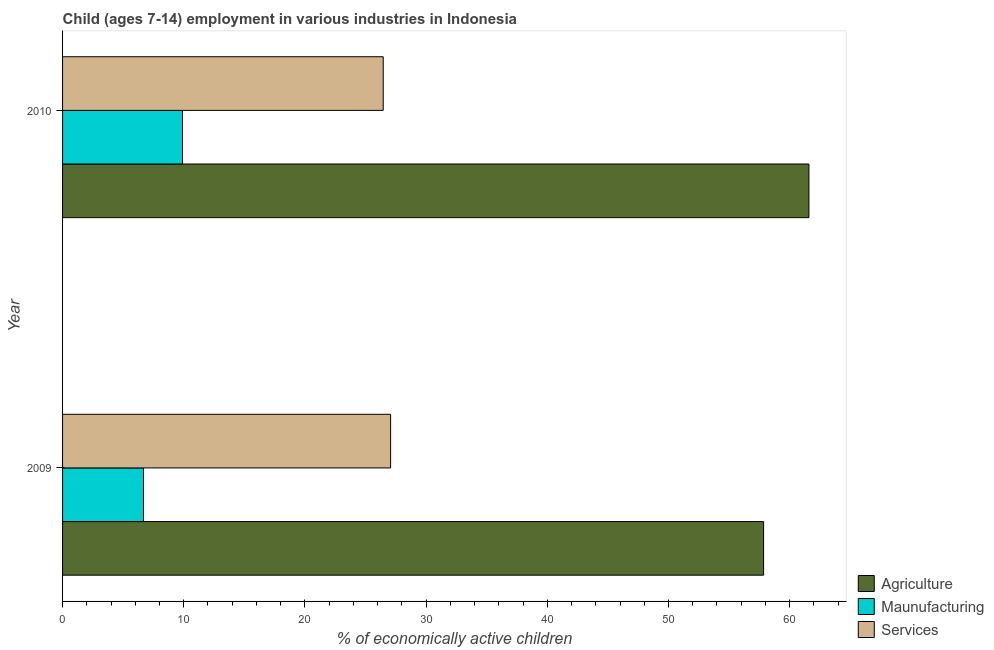How many groups of bars are there?
Make the answer very short. 2. Are the number of bars on each tick of the Y-axis equal?
Provide a short and direct response. Yes. What is the label of the 2nd group of bars from the top?
Ensure brevity in your answer.  2009. What is the percentage of economically active children in manufacturing in 2009?
Give a very brief answer. 6.68. Across all years, what is the maximum percentage of economically active children in agriculture?
Make the answer very short. 61.59. Across all years, what is the minimum percentage of economically active children in services?
Your answer should be compact. 26.46. In which year was the percentage of economically active children in services maximum?
Offer a terse response. 2009. In which year was the percentage of economically active children in services minimum?
Ensure brevity in your answer.  2010. What is the total percentage of economically active children in agriculture in the graph?
Keep it short and to the point. 119.44. What is the difference between the percentage of economically active children in services in 2009 and that in 2010?
Make the answer very short. 0.61. What is the difference between the percentage of economically active children in manufacturing in 2010 and the percentage of economically active children in services in 2009?
Provide a short and direct response. -17.17. What is the average percentage of economically active children in manufacturing per year?
Your answer should be very brief. 8.29. In the year 2009, what is the difference between the percentage of economically active children in agriculture and percentage of economically active children in manufacturing?
Offer a terse response. 51.17. What is the ratio of the percentage of economically active children in manufacturing in 2009 to that in 2010?
Give a very brief answer. 0.68. Is the percentage of economically active children in manufacturing in 2009 less than that in 2010?
Ensure brevity in your answer.  Yes. In how many years, is the percentage of economically active children in manufacturing greater than the average percentage of economically active children in manufacturing taken over all years?
Ensure brevity in your answer.  1. What does the 2nd bar from the top in 2010 represents?
Give a very brief answer. Maunufacturing. What does the 3rd bar from the bottom in 2010 represents?
Provide a short and direct response. Services. Are all the bars in the graph horizontal?
Your answer should be very brief. Yes. What is the difference between two consecutive major ticks on the X-axis?
Give a very brief answer. 10. Does the graph contain grids?
Offer a terse response. No. How are the legend labels stacked?
Give a very brief answer. Vertical. What is the title of the graph?
Ensure brevity in your answer.  Child (ages 7-14) employment in various industries in Indonesia. What is the label or title of the X-axis?
Provide a succinct answer. % of economically active children. What is the % of economically active children of Agriculture in 2009?
Provide a short and direct response. 57.85. What is the % of economically active children of Maunufacturing in 2009?
Your answer should be very brief. 6.68. What is the % of economically active children of Services in 2009?
Provide a succinct answer. 27.07. What is the % of economically active children in Agriculture in 2010?
Ensure brevity in your answer.  61.59. What is the % of economically active children of Services in 2010?
Your response must be concise. 26.46. Across all years, what is the maximum % of economically active children of Agriculture?
Your answer should be very brief. 61.59. Across all years, what is the maximum % of economically active children of Services?
Keep it short and to the point. 27.07. Across all years, what is the minimum % of economically active children in Agriculture?
Ensure brevity in your answer.  57.85. Across all years, what is the minimum % of economically active children of Maunufacturing?
Provide a short and direct response. 6.68. Across all years, what is the minimum % of economically active children in Services?
Make the answer very short. 26.46. What is the total % of economically active children of Agriculture in the graph?
Provide a short and direct response. 119.44. What is the total % of economically active children of Maunufacturing in the graph?
Provide a succinct answer. 16.58. What is the total % of economically active children of Services in the graph?
Provide a short and direct response. 53.53. What is the difference between the % of economically active children of Agriculture in 2009 and that in 2010?
Keep it short and to the point. -3.74. What is the difference between the % of economically active children in Maunufacturing in 2009 and that in 2010?
Give a very brief answer. -3.22. What is the difference between the % of economically active children in Services in 2009 and that in 2010?
Your response must be concise. 0.61. What is the difference between the % of economically active children of Agriculture in 2009 and the % of economically active children of Maunufacturing in 2010?
Your answer should be very brief. 47.95. What is the difference between the % of economically active children of Agriculture in 2009 and the % of economically active children of Services in 2010?
Your answer should be very brief. 31.39. What is the difference between the % of economically active children in Maunufacturing in 2009 and the % of economically active children in Services in 2010?
Provide a short and direct response. -19.78. What is the average % of economically active children in Agriculture per year?
Offer a terse response. 59.72. What is the average % of economically active children of Maunufacturing per year?
Provide a succinct answer. 8.29. What is the average % of economically active children of Services per year?
Your answer should be very brief. 26.77. In the year 2009, what is the difference between the % of economically active children in Agriculture and % of economically active children in Maunufacturing?
Offer a very short reply. 51.17. In the year 2009, what is the difference between the % of economically active children in Agriculture and % of economically active children in Services?
Provide a short and direct response. 30.78. In the year 2009, what is the difference between the % of economically active children of Maunufacturing and % of economically active children of Services?
Keep it short and to the point. -20.39. In the year 2010, what is the difference between the % of economically active children in Agriculture and % of economically active children in Maunufacturing?
Offer a terse response. 51.69. In the year 2010, what is the difference between the % of economically active children in Agriculture and % of economically active children in Services?
Your answer should be compact. 35.13. In the year 2010, what is the difference between the % of economically active children in Maunufacturing and % of economically active children in Services?
Your response must be concise. -16.56. What is the ratio of the % of economically active children of Agriculture in 2009 to that in 2010?
Ensure brevity in your answer.  0.94. What is the ratio of the % of economically active children in Maunufacturing in 2009 to that in 2010?
Ensure brevity in your answer.  0.67. What is the ratio of the % of economically active children in Services in 2009 to that in 2010?
Give a very brief answer. 1.02. What is the difference between the highest and the second highest % of economically active children of Agriculture?
Ensure brevity in your answer.  3.74. What is the difference between the highest and the second highest % of economically active children in Maunufacturing?
Make the answer very short. 3.22. What is the difference between the highest and the second highest % of economically active children of Services?
Offer a terse response. 0.61. What is the difference between the highest and the lowest % of economically active children in Agriculture?
Provide a succinct answer. 3.74. What is the difference between the highest and the lowest % of economically active children in Maunufacturing?
Offer a very short reply. 3.22. What is the difference between the highest and the lowest % of economically active children of Services?
Your answer should be compact. 0.61. 